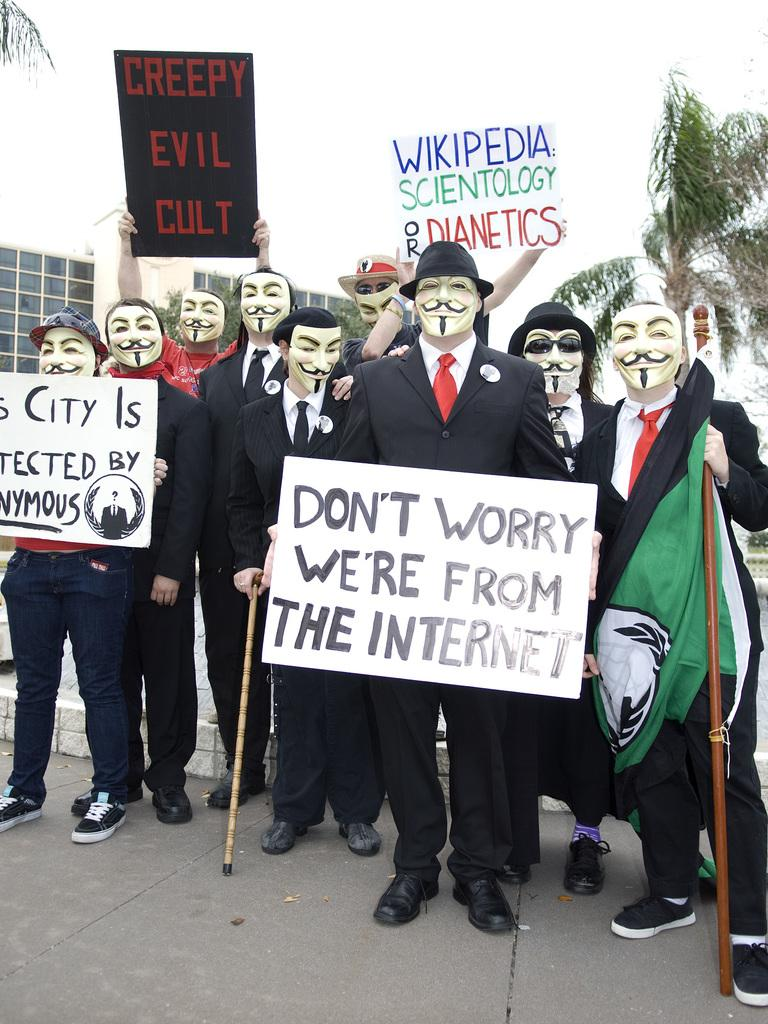<image>
Offer a succinct explanation of the picture presented. A group of men in Guy Fawkes masks hold signs referring to Wikipedia, Scientology and Anonymous. 